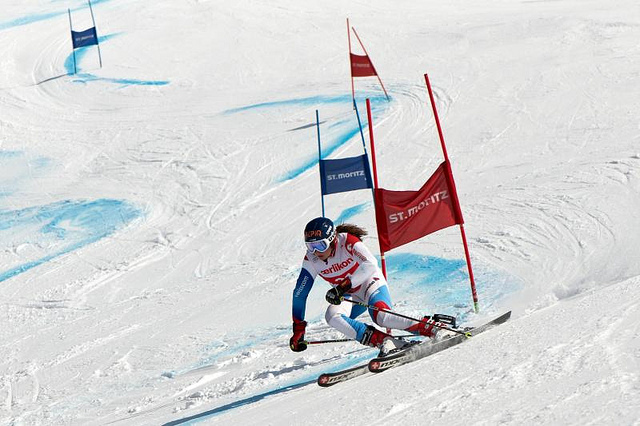Please identify all text content in this image. ST ST moriTZ G 